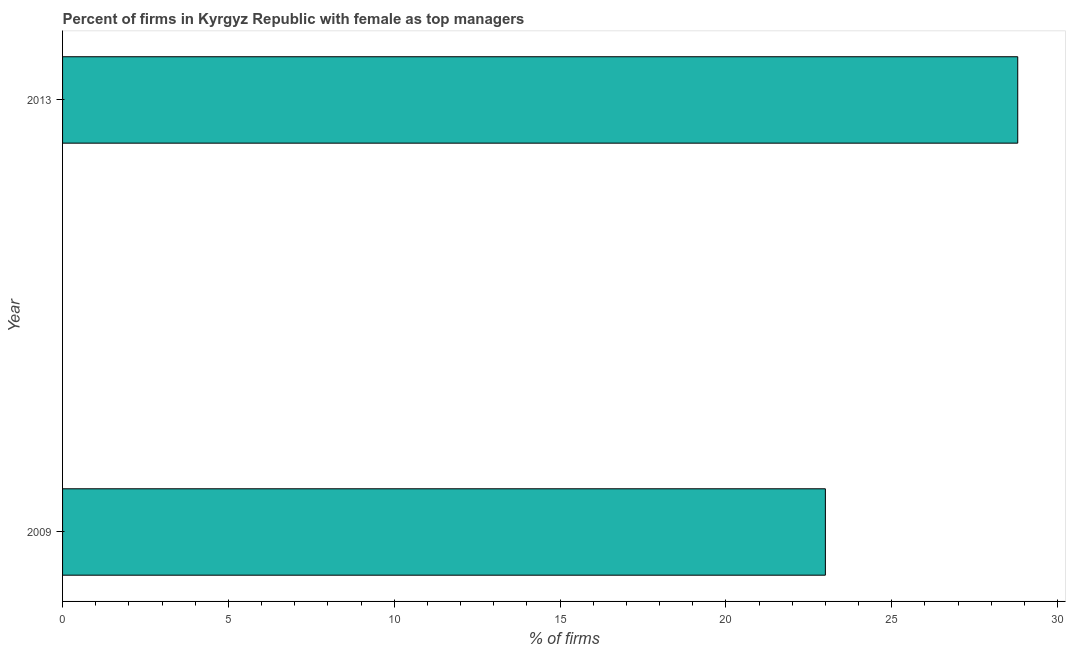Does the graph contain any zero values?
Offer a very short reply. No. What is the title of the graph?
Offer a very short reply. Percent of firms in Kyrgyz Republic with female as top managers. What is the label or title of the X-axis?
Ensure brevity in your answer.  % of firms. Across all years, what is the maximum percentage of firms with female as top manager?
Give a very brief answer. 28.8. In which year was the percentage of firms with female as top manager maximum?
Your answer should be very brief. 2013. In which year was the percentage of firms with female as top manager minimum?
Ensure brevity in your answer.  2009. What is the sum of the percentage of firms with female as top manager?
Your response must be concise. 51.8. What is the difference between the percentage of firms with female as top manager in 2009 and 2013?
Your answer should be very brief. -5.8. What is the average percentage of firms with female as top manager per year?
Your answer should be compact. 25.9. What is the median percentage of firms with female as top manager?
Keep it short and to the point. 25.9. In how many years, is the percentage of firms with female as top manager greater than 27 %?
Your answer should be compact. 1. Do a majority of the years between 2009 and 2013 (inclusive) have percentage of firms with female as top manager greater than 29 %?
Make the answer very short. No. What is the ratio of the percentage of firms with female as top manager in 2009 to that in 2013?
Your response must be concise. 0.8. Are all the bars in the graph horizontal?
Offer a very short reply. Yes. How many years are there in the graph?
Your answer should be compact. 2. Are the values on the major ticks of X-axis written in scientific E-notation?
Your answer should be very brief. No. What is the % of firms in 2009?
Your response must be concise. 23. What is the % of firms of 2013?
Your answer should be very brief. 28.8. What is the ratio of the % of firms in 2009 to that in 2013?
Make the answer very short. 0.8. 